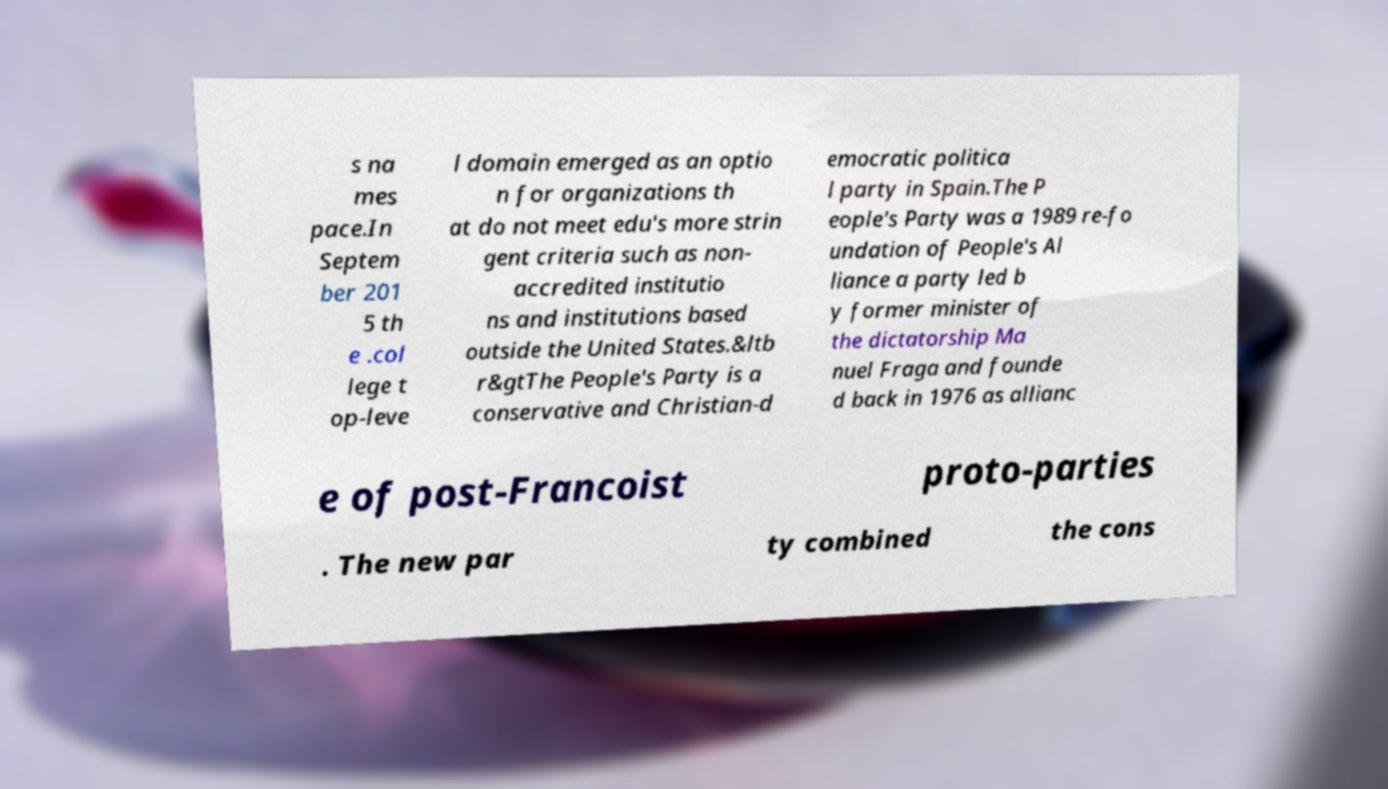Please identify and transcribe the text found in this image. s na mes pace.In Septem ber 201 5 th e .col lege t op-leve l domain emerged as an optio n for organizations th at do not meet edu's more strin gent criteria such as non- accredited institutio ns and institutions based outside the United States.&ltb r&gtThe People's Party is a conservative and Christian-d emocratic politica l party in Spain.The P eople's Party was a 1989 re-fo undation of People's Al liance a party led b y former minister of the dictatorship Ma nuel Fraga and founde d back in 1976 as allianc e of post-Francoist proto-parties . The new par ty combined the cons 